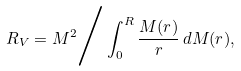Convert formula to latex. <formula><loc_0><loc_0><loc_500><loc_500>R _ { V } = M ^ { 2 } \Big / \int _ { 0 } ^ { R } \frac { M ( r ) } { r } \, d M ( r ) , \Big .</formula> 